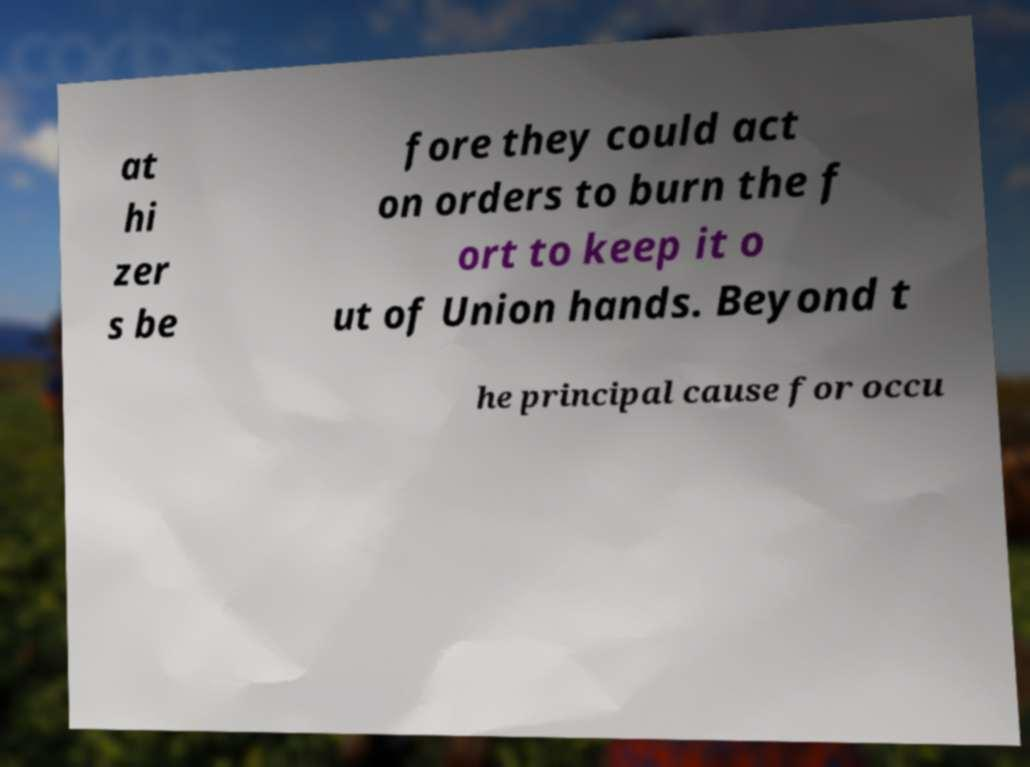I need the written content from this picture converted into text. Can you do that? at hi zer s be fore they could act on orders to burn the f ort to keep it o ut of Union hands. Beyond t he principal cause for occu 